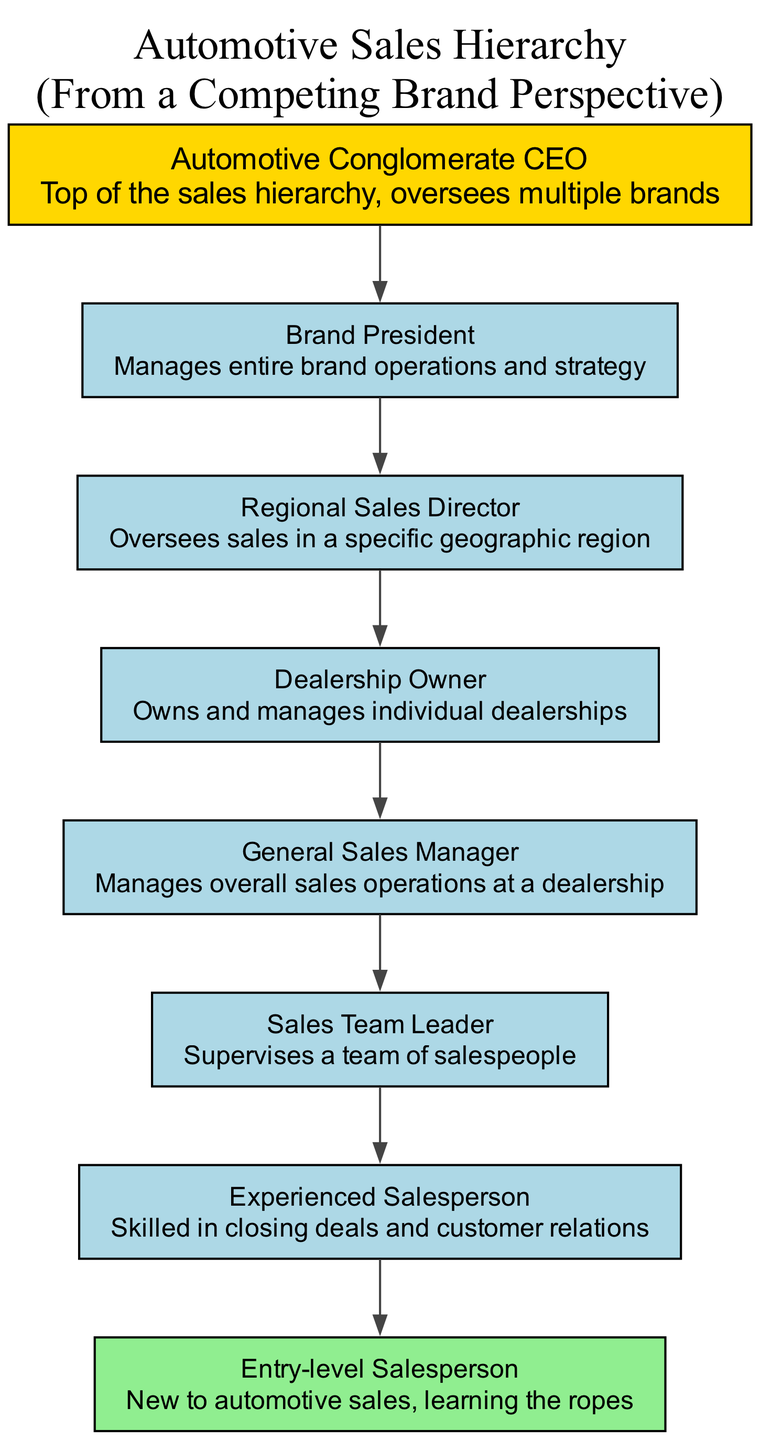What is the top position in the automotive sales hierarchy? The top position is represented by the first element in the diagram, which is the "Automotive Conglomerate CEO." This indicates their role as the leader overseeing multiple brands within the conglomerate.
Answer: Automotive Conglomerate CEO Who manages the entire brand operations? The role responsible for managing all brand operations and strategy is depicted as the "Brand President," which is the second node in the hierarchy. This shows their importance and level in the structure.
Answer: Brand President How many total positions are included in the diagram? By counting the number of elements listed in the diagram, there are eight distinct positions outlined, which reflect the full chain of command from the CEO to entry-level salespeople.
Answer: Eight Which position directly supervises the sales team? The "Sales Team Leader," as the one right below the "General Sales Manager," is the position that directly supervises the team of salespeople, indicating their leadership role within the dealership operations.
Answer: Sales Team Leader What is the role of the second from the bottom position? The second from the bottom position is the "Experienced Salesperson," indicating that they are knowledgeable and skilled in closing deals and managing customer relations, providing support to less experienced team members.
Answer: Skilled in closing deals and customer relations Which position has the least experience and is new to automotive sales? The "Entry-level Salesperson" is the position designated for individuals who are new to automotive sales, as indicated in the diagram. This captures their status as learners in the sales process.
Answer: Entry-level Salesperson Who is responsible for overseeing sales in a specific geographic region? The "Regional Sales Director" monitors and manages sales activities focused on a distinct geographic area, showing responsibility for wider operational success beyond a single dealership.
Answer: Regional Sales Director Which role comes just before the Entry-level Salesperson in the hierarchy? Directly above the "Entry-level Salesperson" in the hierarchy is the "Experienced Salesperson," indicating a progression in expertise and responsibility for newcomers within the sales team.
Answer: Experienced Salesperson 